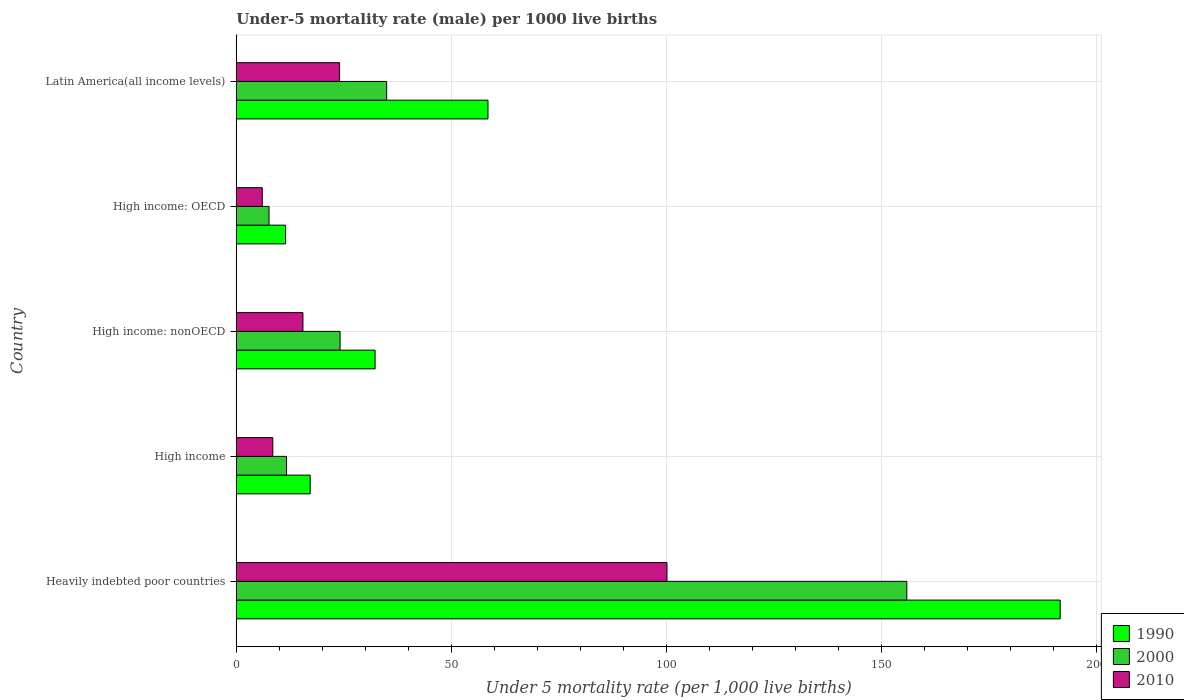How many groups of bars are there?
Keep it short and to the point. 5. Are the number of bars per tick equal to the number of legend labels?
Your response must be concise. Yes. Are the number of bars on each tick of the Y-axis equal?
Your answer should be compact. Yes. What is the label of the 1st group of bars from the top?
Provide a succinct answer. Latin America(all income levels). In how many cases, is the number of bars for a given country not equal to the number of legend labels?
Offer a very short reply. 0. What is the under-five mortality rate in 1990 in High income: OECD?
Give a very brief answer. 11.47. Across all countries, what is the maximum under-five mortality rate in 1990?
Your answer should be very brief. 191.65. Across all countries, what is the minimum under-five mortality rate in 1990?
Provide a short and direct response. 11.47. In which country was the under-five mortality rate in 1990 maximum?
Your answer should be very brief. Heavily indebted poor countries. In which country was the under-five mortality rate in 2000 minimum?
Your answer should be very brief. High income: OECD. What is the total under-five mortality rate in 1990 in the graph?
Make the answer very short. 311.18. What is the difference between the under-five mortality rate in 2000 in Heavily indebted poor countries and that in High income?
Provide a succinct answer. 144.28. What is the difference between the under-five mortality rate in 2000 in High income: OECD and the under-five mortality rate in 1990 in High income: nonOECD?
Make the answer very short. -24.68. What is the average under-five mortality rate in 2000 per country?
Ensure brevity in your answer.  46.89. What is the difference between the under-five mortality rate in 2000 and under-five mortality rate in 1990 in High income: OECD?
Your response must be concise. -3.85. What is the ratio of the under-five mortality rate in 2010 in High income to that in Latin America(all income levels)?
Make the answer very short. 0.35. Is the under-five mortality rate in 1990 in High income: nonOECD less than that in Latin America(all income levels)?
Give a very brief answer. Yes. Is the difference between the under-five mortality rate in 2000 in High income: OECD and Latin America(all income levels) greater than the difference between the under-five mortality rate in 1990 in High income: OECD and Latin America(all income levels)?
Your response must be concise. Yes. What is the difference between the highest and the second highest under-five mortality rate in 2010?
Your response must be concise. 76.15. What is the difference between the highest and the lowest under-five mortality rate in 2000?
Give a very brief answer. 148.36. In how many countries, is the under-five mortality rate in 2010 greater than the average under-five mortality rate in 2010 taken over all countries?
Provide a short and direct response. 1. Is the sum of the under-five mortality rate in 2010 in High income and Latin America(all income levels) greater than the maximum under-five mortality rate in 2000 across all countries?
Your answer should be compact. No. What does the 2nd bar from the top in Heavily indebted poor countries represents?
Offer a very short reply. 2000. What does the 2nd bar from the bottom in High income represents?
Your response must be concise. 2000. How many bars are there?
Your response must be concise. 15. How many countries are there in the graph?
Your answer should be very brief. 5. What is the difference between two consecutive major ticks on the X-axis?
Your answer should be very brief. 50. Are the values on the major ticks of X-axis written in scientific E-notation?
Your answer should be very brief. No. Does the graph contain grids?
Ensure brevity in your answer.  Yes. How are the legend labels stacked?
Provide a succinct answer. Vertical. What is the title of the graph?
Your answer should be compact. Under-5 mortality rate (male) per 1000 live births. What is the label or title of the X-axis?
Offer a very short reply. Under 5 mortality rate (per 1,0 live births). What is the label or title of the Y-axis?
Offer a very short reply. Country. What is the Under 5 mortality rate (per 1,000 live births) in 1990 in Heavily indebted poor countries?
Make the answer very short. 191.65. What is the Under 5 mortality rate (per 1,000 live births) of 2000 in Heavily indebted poor countries?
Your answer should be compact. 155.98. What is the Under 5 mortality rate (per 1,000 live births) in 2010 in Heavily indebted poor countries?
Offer a very short reply. 100.19. What is the Under 5 mortality rate (per 1,000 live births) of 2000 in High income?
Provide a succinct answer. 11.7. What is the Under 5 mortality rate (per 1,000 live births) of 1990 in High income: nonOECD?
Keep it short and to the point. 32.3. What is the Under 5 mortality rate (per 1,000 live births) in 2000 in High income: nonOECD?
Your response must be concise. 24.15. What is the Under 5 mortality rate (per 1,000 live births) of 2010 in High income: nonOECD?
Your answer should be compact. 15.51. What is the Under 5 mortality rate (per 1,000 live births) of 1990 in High income: OECD?
Ensure brevity in your answer.  11.47. What is the Under 5 mortality rate (per 1,000 live births) of 2000 in High income: OECD?
Provide a short and direct response. 7.62. What is the Under 5 mortality rate (per 1,000 live births) in 2010 in High income: OECD?
Make the answer very short. 6.05. What is the Under 5 mortality rate (per 1,000 live births) of 1990 in Latin America(all income levels)?
Ensure brevity in your answer.  58.55. What is the Under 5 mortality rate (per 1,000 live births) in 2000 in Latin America(all income levels)?
Your answer should be compact. 34.99. What is the Under 5 mortality rate (per 1,000 live births) of 2010 in Latin America(all income levels)?
Make the answer very short. 24.04. Across all countries, what is the maximum Under 5 mortality rate (per 1,000 live births) of 1990?
Give a very brief answer. 191.65. Across all countries, what is the maximum Under 5 mortality rate (per 1,000 live births) in 2000?
Offer a very short reply. 155.98. Across all countries, what is the maximum Under 5 mortality rate (per 1,000 live births) of 2010?
Make the answer very short. 100.19. Across all countries, what is the minimum Under 5 mortality rate (per 1,000 live births) of 1990?
Ensure brevity in your answer.  11.47. Across all countries, what is the minimum Under 5 mortality rate (per 1,000 live births) in 2000?
Your answer should be very brief. 7.62. Across all countries, what is the minimum Under 5 mortality rate (per 1,000 live births) in 2010?
Ensure brevity in your answer.  6.05. What is the total Under 5 mortality rate (per 1,000 live births) in 1990 in the graph?
Provide a succinct answer. 311.18. What is the total Under 5 mortality rate (per 1,000 live births) in 2000 in the graph?
Offer a very short reply. 234.44. What is the total Under 5 mortality rate (per 1,000 live births) of 2010 in the graph?
Provide a succinct answer. 154.29. What is the difference between the Under 5 mortality rate (per 1,000 live births) of 1990 in Heavily indebted poor countries and that in High income?
Offer a very short reply. 174.45. What is the difference between the Under 5 mortality rate (per 1,000 live births) in 2000 in Heavily indebted poor countries and that in High income?
Offer a very short reply. 144.28. What is the difference between the Under 5 mortality rate (per 1,000 live births) of 2010 in Heavily indebted poor countries and that in High income?
Give a very brief answer. 91.69. What is the difference between the Under 5 mortality rate (per 1,000 live births) of 1990 in Heavily indebted poor countries and that in High income: nonOECD?
Provide a succinct answer. 159.36. What is the difference between the Under 5 mortality rate (per 1,000 live births) of 2000 in Heavily indebted poor countries and that in High income: nonOECD?
Make the answer very short. 131.83. What is the difference between the Under 5 mortality rate (per 1,000 live births) in 2010 in Heavily indebted poor countries and that in High income: nonOECD?
Provide a succinct answer. 84.68. What is the difference between the Under 5 mortality rate (per 1,000 live births) of 1990 in Heavily indebted poor countries and that in High income: OECD?
Offer a terse response. 180.18. What is the difference between the Under 5 mortality rate (per 1,000 live births) in 2000 in Heavily indebted poor countries and that in High income: OECD?
Make the answer very short. 148.36. What is the difference between the Under 5 mortality rate (per 1,000 live births) of 2010 in Heavily indebted poor countries and that in High income: OECD?
Your answer should be very brief. 94.14. What is the difference between the Under 5 mortality rate (per 1,000 live births) of 1990 in Heavily indebted poor countries and that in Latin America(all income levels)?
Ensure brevity in your answer.  133.1. What is the difference between the Under 5 mortality rate (per 1,000 live births) of 2000 in Heavily indebted poor countries and that in Latin America(all income levels)?
Provide a short and direct response. 120.99. What is the difference between the Under 5 mortality rate (per 1,000 live births) in 2010 in Heavily indebted poor countries and that in Latin America(all income levels)?
Give a very brief answer. 76.15. What is the difference between the Under 5 mortality rate (per 1,000 live births) in 1990 in High income and that in High income: nonOECD?
Offer a very short reply. -15.1. What is the difference between the Under 5 mortality rate (per 1,000 live births) in 2000 in High income and that in High income: nonOECD?
Ensure brevity in your answer.  -12.45. What is the difference between the Under 5 mortality rate (per 1,000 live births) in 2010 in High income and that in High income: nonOECD?
Your response must be concise. -7.01. What is the difference between the Under 5 mortality rate (per 1,000 live births) in 1990 in High income and that in High income: OECD?
Offer a terse response. 5.73. What is the difference between the Under 5 mortality rate (per 1,000 live births) in 2000 in High income and that in High income: OECD?
Provide a short and direct response. 4.08. What is the difference between the Under 5 mortality rate (per 1,000 live births) in 2010 in High income and that in High income: OECD?
Offer a terse response. 2.45. What is the difference between the Under 5 mortality rate (per 1,000 live births) in 1990 in High income and that in Latin America(all income levels)?
Ensure brevity in your answer.  -41.35. What is the difference between the Under 5 mortality rate (per 1,000 live births) in 2000 in High income and that in Latin America(all income levels)?
Your answer should be compact. -23.29. What is the difference between the Under 5 mortality rate (per 1,000 live births) of 2010 in High income and that in Latin America(all income levels)?
Your response must be concise. -15.54. What is the difference between the Under 5 mortality rate (per 1,000 live births) in 1990 in High income: nonOECD and that in High income: OECD?
Your answer should be compact. 20.82. What is the difference between the Under 5 mortality rate (per 1,000 live births) of 2000 in High income: nonOECD and that in High income: OECD?
Your answer should be compact. 16.53. What is the difference between the Under 5 mortality rate (per 1,000 live births) in 2010 in High income: nonOECD and that in High income: OECD?
Offer a very short reply. 9.46. What is the difference between the Under 5 mortality rate (per 1,000 live births) of 1990 in High income: nonOECD and that in Latin America(all income levels)?
Make the answer very short. -26.26. What is the difference between the Under 5 mortality rate (per 1,000 live births) of 2000 in High income: nonOECD and that in Latin America(all income levels)?
Offer a very short reply. -10.84. What is the difference between the Under 5 mortality rate (per 1,000 live births) of 2010 in High income: nonOECD and that in Latin America(all income levels)?
Offer a terse response. -8.53. What is the difference between the Under 5 mortality rate (per 1,000 live births) of 1990 in High income: OECD and that in Latin America(all income levels)?
Ensure brevity in your answer.  -47.08. What is the difference between the Under 5 mortality rate (per 1,000 live births) in 2000 in High income: OECD and that in Latin America(all income levels)?
Your answer should be compact. -27.37. What is the difference between the Under 5 mortality rate (per 1,000 live births) in 2010 in High income: OECD and that in Latin America(all income levels)?
Offer a terse response. -17.99. What is the difference between the Under 5 mortality rate (per 1,000 live births) in 1990 in Heavily indebted poor countries and the Under 5 mortality rate (per 1,000 live births) in 2000 in High income?
Make the answer very short. 179.95. What is the difference between the Under 5 mortality rate (per 1,000 live births) in 1990 in Heavily indebted poor countries and the Under 5 mortality rate (per 1,000 live births) in 2010 in High income?
Give a very brief answer. 183.15. What is the difference between the Under 5 mortality rate (per 1,000 live births) of 2000 in Heavily indebted poor countries and the Under 5 mortality rate (per 1,000 live births) of 2010 in High income?
Give a very brief answer. 147.48. What is the difference between the Under 5 mortality rate (per 1,000 live births) of 1990 in Heavily indebted poor countries and the Under 5 mortality rate (per 1,000 live births) of 2000 in High income: nonOECD?
Your answer should be very brief. 167.5. What is the difference between the Under 5 mortality rate (per 1,000 live births) in 1990 in Heavily indebted poor countries and the Under 5 mortality rate (per 1,000 live births) in 2010 in High income: nonOECD?
Keep it short and to the point. 176.14. What is the difference between the Under 5 mortality rate (per 1,000 live births) of 2000 in Heavily indebted poor countries and the Under 5 mortality rate (per 1,000 live births) of 2010 in High income: nonOECD?
Provide a succinct answer. 140.47. What is the difference between the Under 5 mortality rate (per 1,000 live births) of 1990 in Heavily indebted poor countries and the Under 5 mortality rate (per 1,000 live births) of 2000 in High income: OECD?
Provide a short and direct response. 184.03. What is the difference between the Under 5 mortality rate (per 1,000 live births) of 1990 in Heavily indebted poor countries and the Under 5 mortality rate (per 1,000 live births) of 2010 in High income: OECD?
Ensure brevity in your answer.  185.6. What is the difference between the Under 5 mortality rate (per 1,000 live births) of 2000 in Heavily indebted poor countries and the Under 5 mortality rate (per 1,000 live births) of 2010 in High income: OECD?
Give a very brief answer. 149.93. What is the difference between the Under 5 mortality rate (per 1,000 live births) of 1990 in Heavily indebted poor countries and the Under 5 mortality rate (per 1,000 live births) of 2000 in Latin America(all income levels)?
Keep it short and to the point. 156.66. What is the difference between the Under 5 mortality rate (per 1,000 live births) of 1990 in Heavily indebted poor countries and the Under 5 mortality rate (per 1,000 live births) of 2010 in Latin America(all income levels)?
Your response must be concise. 167.62. What is the difference between the Under 5 mortality rate (per 1,000 live births) in 2000 in Heavily indebted poor countries and the Under 5 mortality rate (per 1,000 live births) in 2010 in Latin America(all income levels)?
Offer a terse response. 131.95. What is the difference between the Under 5 mortality rate (per 1,000 live births) in 1990 in High income and the Under 5 mortality rate (per 1,000 live births) in 2000 in High income: nonOECD?
Offer a very short reply. -6.95. What is the difference between the Under 5 mortality rate (per 1,000 live births) of 1990 in High income and the Under 5 mortality rate (per 1,000 live births) of 2010 in High income: nonOECD?
Offer a very short reply. 1.69. What is the difference between the Under 5 mortality rate (per 1,000 live births) in 2000 in High income and the Under 5 mortality rate (per 1,000 live births) in 2010 in High income: nonOECD?
Your answer should be compact. -3.81. What is the difference between the Under 5 mortality rate (per 1,000 live births) in 1990 in High income and the Under 5 mortality rate (per 1,000 live births) in 2000 in High income: OECD?
Provide a short and direct response. 9.58. What is the difference between the Under 5 mortality rate (per 1,000 live births) of 1990 in High income and the Under 5 mortality rate (per 1,000 live births) of 2010 in High income: OECD?
Keep it short and to the point. 11.15. What is the difference between the Under 5 mortality rate (per 1,000 live births) of 2000 in High income and the Under 5 mortality rate (per 1,000 live births) of 2010 in High income: OECD?
Your answer should be very brief. 5.65. What is the difference between the Under 5 mortality rate (per 1,000 live births) of 1990 in High income and the Under 5 mortality rate (per 1,000 live births) of 2000 in Latin America(all income levels)?
Offer a terse response. -17.79. What is the difference between the Under 5 mortality rate (per 1,000 live births) of 1990 in High income and the Under 5 mortality rate (per 1,000 live births) of 2010 in Latin America(all income levels)?
Your response must be concise. -6.84. What is the difference between the Under 5 mortality rate (per 1,000 live births) in 2000 in High income and the Under 5 mortality rate (per 1,000 live births) in 2010 in Latin America(all income levels)?
Your answer should be very brief. -12.34. What is the difference between the Under 5 mortality rate (per 1,000 live births) of 1990 in High income: nonOECD and the Under 5 mortality rate (per 1,000 live births) of 2000 in High income: OECD?
Your answer should be very brief. 24.68. What is the difference between the Under 5 mortality rate (per 1,000 live births) in 1990 in High income: nonOECD and the Under 5 mortality rate (per 1,000 live births) in 2010 in High income: OECD?
Your answer should be compact. 26.25. What is the difference between the Under 5 mortality rate (per 1,000 live births) in 2000 in High income: nonOECD and the Under 5 mortality rate (per 1,000 live births) in 2010 in High income: OECD?
Make the answer very short. 18.1. What is the difference between the Under 5 mortality rate (per 1,000 live births) of 1990 in High income: nonOECD and the Under 5 mortality rate (per 1,000 live births) of 2000 in Latin America(all income levels)?
Offer a very short reply. -2.69. What is the difference between the Under 5 mortality rate (per 1,000 live births) in 1990 in High income: nonOECD and the Under 5 mortality rate (per 1,000 live births) in 2010 in Latin America(all income levels)?
Give a very brief answer. 8.26. What is the difference between the Under 5 mortality rate (per 1,000 live births) of 2000 in High income: nonOECD and the Under 5 mortality rate (per 1,000 live births) of 2010 in Latin America(all income levels)?
Ensure brevity in your answer.  0.11. What is the difference between the Under 5 mortality rate (per 1,000 live births) of 1990 in High income: OECD and the Under 5 mortality rate (per 1,000 live births) of 2000 in Latin America(all income levels)?
Ensure brevity in your answer.  -23.51. What is the difference between the Under 5 mortality rate (per 1,000 live births) of 1990 in High income: OECD and the Under 5 mortality rate (per 1,000 live births) of 2010 in Latin America(all income levels)?
Your answer should be very brief. -12.56. What is the difference between the Under 5 mortality rate (per 1,000 live births) of 2000 in High income: OECD and the Under 5 mortality rate (per 1,000 live births) of 2010 in Latin America(all income levels)?
Offer a terse response. -16.41. What is the average Under 5 mortality rate (per 1,000 live births) in 1990 per country?
Provide a short and direct response. 62.24. What is the average Under 5 mortality rate (per 1,000 live births) in 2000 per country?
Offer a very short reply. 46.89. What is the average Under 5 mortality rate (per 1,000 live births) of 2010 per country?
Your answer should be very brief. 30.86. What is the difference between the Under 5 mortality rate (per 1,000 live births) in 1990 and Under 5 mortality rate (per 1,000 live births) in 2000 in Heavily indebted poor countries?
Keep it short and to the point. 35.67. What is the difference between the Under 5 mortality rate (per 1,000 live births) in 1990 and Under 5 mortality rate (per 1,000 live births) in 2010 in Heavily indebted poor countries?
Your answer should be very brief. 91.46. What is the difference between the Under 5 mortality rate (per 1,000 live births) of 2000 and Under 5 mortality rate (per 1,000 live births) of 2010 in Heavily indebted poor countries?
Provide a short and direct response. 55.79. What is the difference between the Under 5 mortality rate (per 1,000 live births) in 1990 and Under 5 mortality rate (per 1,000 live births) in 2010 in High income?
Offer a terse response. 8.7. What is the difference between the Under 5 mortality rate (per 1,000 live births) of 1990 and Under 5 mortality rate (per 1,000 live births) of 2000 in High income: nonOECD?
Offer a very short reply. 8.15. What is the difference between the Under 5 mortality rate (per 1,000 live births) of 1990 and Under 5 mortality rate (per 1,000 live births) of 2010 in High income: nonOECD?
Keep it short and to the point. 16.79. What is the difference between the Under 5 mortality rate (per 1,000 live births) in 2000 and Under 5 mortality rate (per 1,000 live births) in 2010 in High income: nonOECD?
Your answer should be compact. 8.64. What is the difference between the Under 5 mortality rate (per 1,000 live births) in 1990 and Under 5 mortality rate (per 1,000 live births) in 2000 in High income: OECD?
Your response must be concise. 3.85. What is the difference between the Under 5 mortality rate (per 1,000 live births) of 1990 and Under 5 mortality rate (per 1,000 live births) of 2010 in High income: OECD?
Ensure brevity in your answer.  5.42. What is the difference between the Under 5 mortality rate (per 1,000 live births) of 2000 and Under 5 mortality rate (per 1,000 live births) of 2010 in High income: OECD?
Offer a terse response. 1.57. What is the difference between the Under 5 mortality rate (per 1,000 live births) in 1990 and Under 5 mortality rate (per 1,000 live births) in 2000 in Latin America(all income levels)?
Give a very brief answer. 23.57. What is the difference between the Under 5 mortality rate (per 1,000 live births) in 1990 and Under 5 mortality rate (per 1,000 live births) in 2010 in Latin America(all income levels)?
Give a very brief answer. 34.52. What is the difference between the Under 5 mortality rate (per 1,000 live births) in 2000 and Under 5 mortality rate (per 1,000 live births) in 2010 in Latin America(all income levels)?
Make the answer very short. 10.95. What is the ratio of the Under 5 mortality rate (per 1,000 live births) in 1990 in Heavily indebted poor countries to that in High income?
Offer a terse response. 11.14. What is the ratio of the Under 5 mortality rate (per 1,000 live births) of 2000 in Heavily indebted poor countries to that in High income?
Ensure brevity in your answer.  13.33. What is the ratio of the Under 5 mortality rate (per 1,000 live births) of 2010 in Heavily indebted poor countries to that in High income?
Ensure brevity in your answer.  11.79. What is the ratio of the Under 5 mortality rate (per 1,000 live births) of 1990 in Heavily indebted poor countries to that in High income: nonOECD?
Give a very brief answer. 5.93. What is the ratio of the Under 5 mortality rate (per 1,000 live births) of 2000 in Heavily indebted poor countries to that in High income: nonOECD?
Offer a very short reply. 6.46. What is the ratio of the Under 5 mortality rate (per 1,000 live births) of 2010 in Heavily indebted poor countries to that in High income: nonOECD?
Your response must be concise. 6.46. What is the ratio of the Under 5 mortality rate (per 1,000 live births) in 1990 in Heavily indebted poor countries to that in High income: OECD?
Your response must be concise. 16.7. What is the ratio of the Under 5 mortality rate (per 1,000 live births) of 2000 in Heavily indebted poor countries to that in High income: OECD?
Your answer should be compact. 20.46. What is the ratio of the Under 5 mortality rate (per 1,000 live births) of 2010 in Heavily indebted poor countries to that in High income: OECD?
Offer a very short reply. 16.56. What is the ratio of the Under 5 mortality rate (per 1,000 live births) in 1990 in Heavily indebted poor countries to that in Latin America(all income levels)?
Give a very brief answer. 3.27. What is the ratio of the Under 5 mortality rate (per 1,000 live births) of 2000 in Heavily indebted poor countries to that in Latin America(all income levels)?
Keep it short and to the point. 4.46. What is the ratio of the Under 5 mortality rate (per 1,000 live births) in 2010 in Heavily indebted poor countries to that in Latin America(all income levels)?
Provide a succinct answer. 4.17. What is the ratio of the Under 5 mortality rate (per 1,000 live births) in 1990 in High income to that in High income: nonOECD?
Your answer should be compact. 0.53. What is the ratio of the Under 5 mortality rate (per 1,000 live births) in 2000 in High income to that in High income: nonOECD?
Provide a succinct answer. 0.48. What is the ratio of the Under 5 mortality rate (per 1,000 live births) of 2010 in High income to that in High income: nonOECD?
Give a very brief answer. 0.55. What is the ratio of the Under 5 mortality rate (per 1,000 live births) in 1990 in High income to that in High income: OECD?
Provide a succinct answer. 1.5. What is the ratio of the Under 5 mortality rate (per 1,000 live births) of 2000 in High income to that in High income: OECD?
Provide a short and direct response. 1.53. What is the ratio of the Under 5 mortality rate (per 1,000 live births) of 2010 in High income to that in High income: OECD?
Offer a terse response. 1.4. What is the ratio of the Under 5 mortality rate (per 1,000 live births) of 1990 in High income to that in Latin America(all income levels)?
Make the answer very short. 0.29. What is the ratio of the Under 5 mortality rate (per 1,000 live births) in 2000 in High income to that in Latin America(all income levels)?
Provide a short and direct response. 0.33. What is the ratio of the Under 5 mortality rate (per 1,000 live births) of 2010 in High income to that in Latin America(all income levels)?
Your answer should be very brief. 0.35. What is the ratio of the Under 5 mortality rate (per 1,000 live births) of 1990 in High income: nonOECD to that in High income: OECD?
Your answer should be compact. 2.81. What is the ratio of the Under 5 mortality rate (per 1,000 live births) of 2000 in High income: nonOECD to that in High income: OECD?
Offer a terse response. 3.17. What is the ratio of the Under 5 mortality rate (per 1,000 live births) of 2010 in High income: nonOECD to that in High income: OECD?
Give a very brief answer. 2.56. What is the ratio of the Under 5 mortality rate (per 1,000 live births) in 1990 in High income: nonOECD to that in Latin America(all income levels)?
Keep it short and to the point. 0.55. What is the ratio of the Under 5 mortality rate (per 1,000 live births) in 2000 in High income: nonOECD to that in Latin America(all income levels)?
Give a very brief answer. 0.69. What is the ratio of the Under 5 mortality rate (per 1,000 live births) in 2010 in High income: nonOECD to that in Latin America(all income levels)?
Your answer should be compact. 0.65. What is the ratio of the Under 5 mortality rate (per 1,000 live births) of 1990 in High income: OECD to that in Latin America(all income levels)?
Provide a succinct answer. 0.2. What is the ratio of the Under 5 mortality rate (per 1,000 live births) in 2000 in High income: OECD to that in Latin America(all income levels)?
Make the answer very short. 0.22. What is the ratio of the Under 5 mortality rate (per 1,000 live births) in 2010 in High income: OECD to that in Latin America(all income levels)?
Offer a very short reply. 0.25. What is the difference between the highest and the second highest Under 5 mortality rate (per 1,000 live births) of 1990?
Provide a short and direct response. 133.1. What is the difference between the highest and the second highest Under 5 mortality rate (per 1,000 live births) of 2000?
Your response must be concise. 120.99. What is the difference between the highest and the second highest Under 5 mortality rate (per 1,000 live births) in 2010?
Provide a succinct answer. 76.15. What is the difference between the highest and the lowest Under 5 mortality rate (per 1,000 live births) in 1990?
Ensure brevity in your answer.  180.18. What is the difference between the highest and the lowest Under 5 mortality rate (per 1,000 live births) of 2000?
Offer a terse response. 148.36. What is the difference between the highest and the lowest Under 5 mortality rate (per 1,000 live births) of 2010?
Offer a terse response. 94.14. 